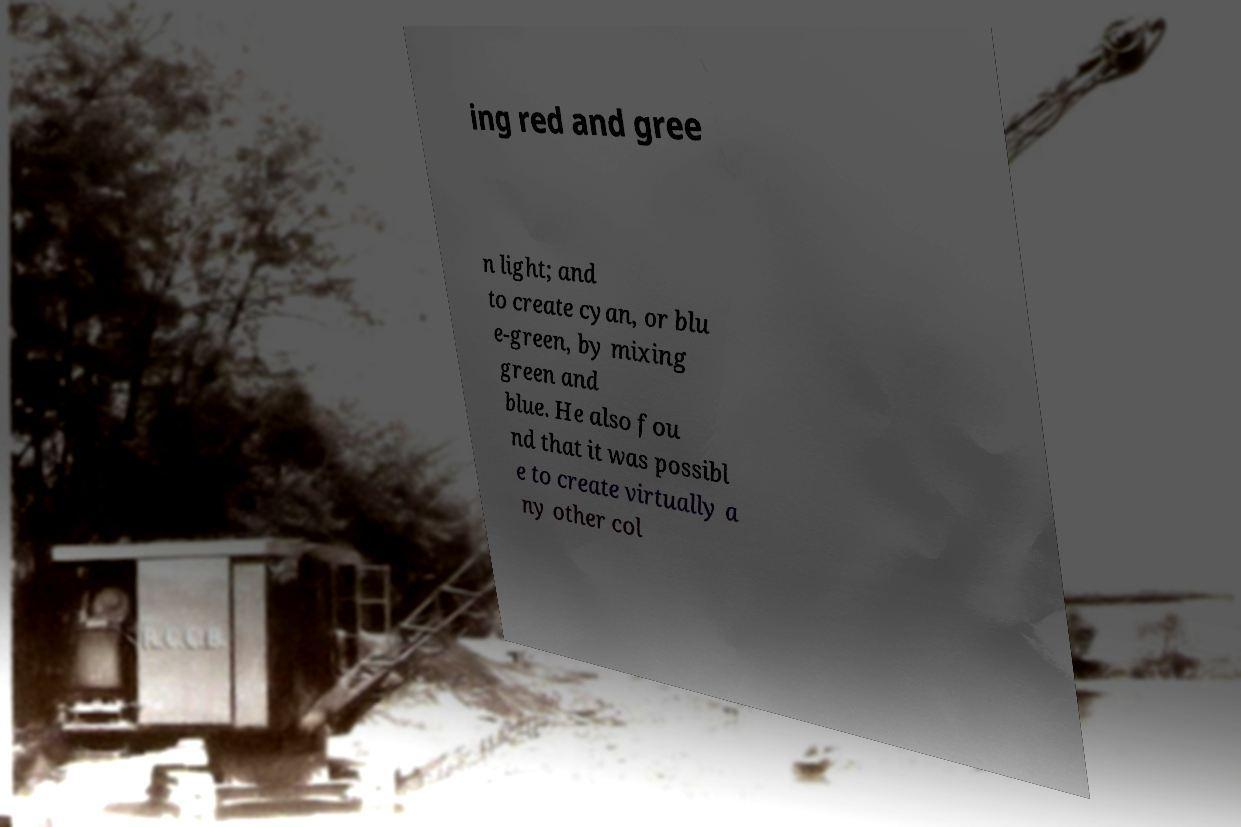Could you assist in decoding the text presented in this image and type it out clearly? ing red and gree n light; and to create cyan, or blu e-green, by mixing green and blue. He also fou nd that it was possibl e to create virtually a ny other col 